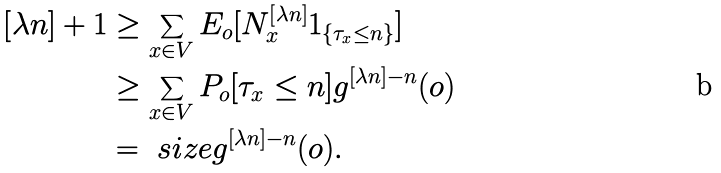<formula> <loc_0><loc_0><loc_500><loc_500>[ \lambda n ] + 1 & \geq \sum _ { x \in V } E _ { o } [ N ^ { [ \lambda n ] } _ { x } 1 _ { \{ \tau _ { x } \leq n \} } ] \\ & \geq \sum _ { x \in V } P _ { o } [ \tau _ { x } \leq n ] g ^ { [ \lambda n ] - n } ( o ) \\ & = \ s i z e g ^ { [ \lambda n ] - n } ( o ) .</formula> 